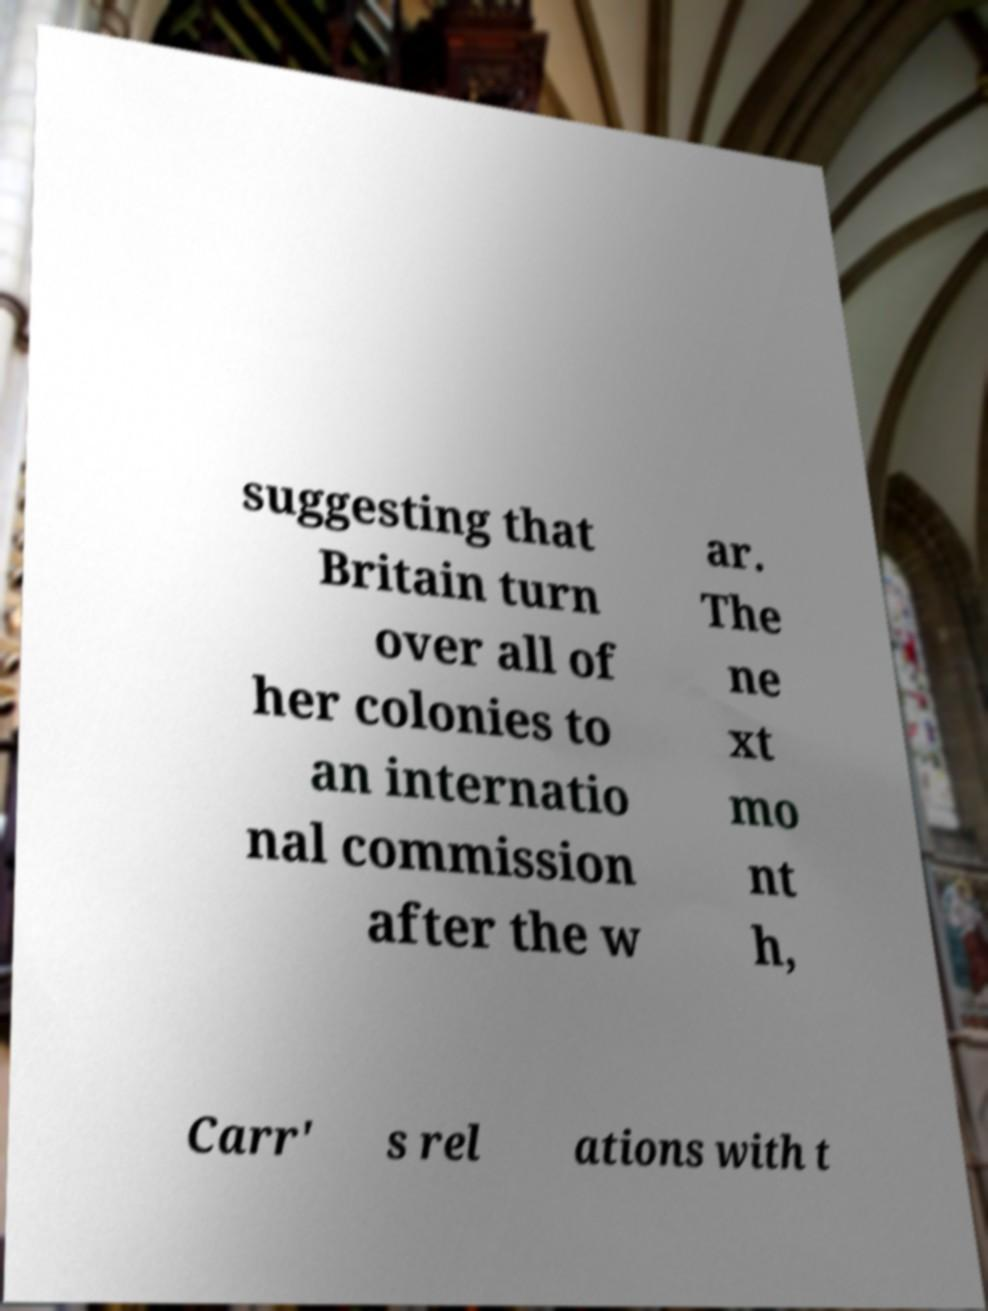There's text embedded in this image that I need extracted. Can you transcribe it verbatim? suggesting that Britain turn over all of her colonies to an internatio nal commission after the w ar. The ne xt mo nt h, Carr' s rel ations with t 